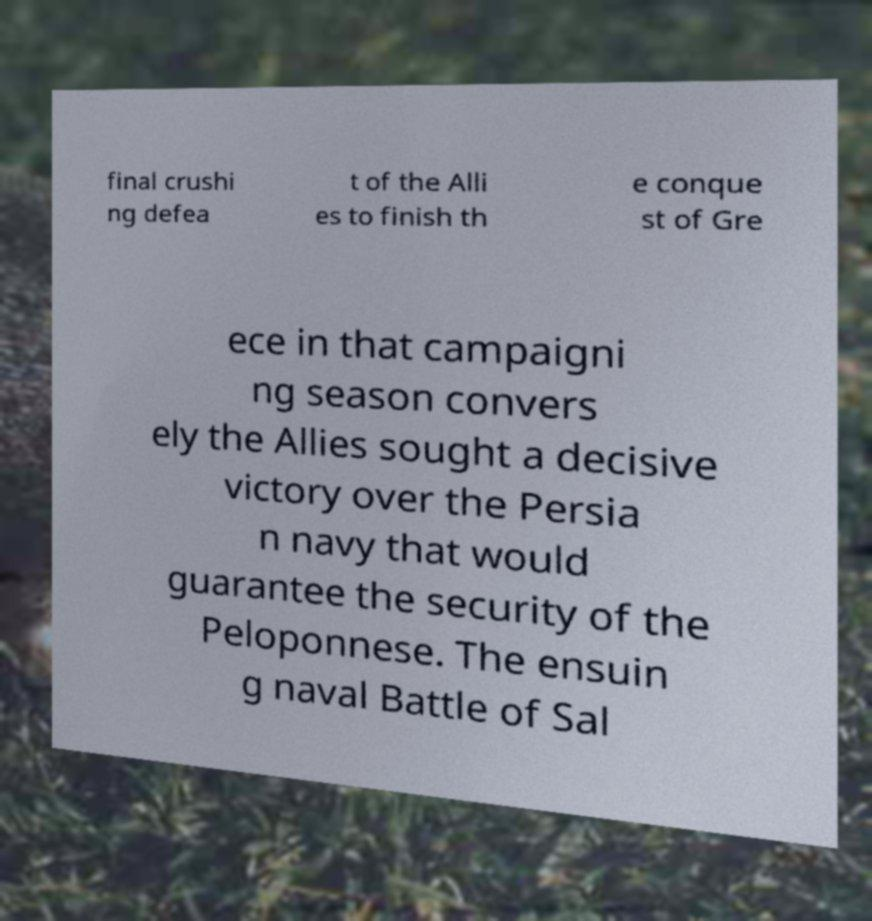Could you extract and type out the text from this image? final crushi ng defea t of the Alli es to finish th e conque st of Gre ece in that campaigni ng season convers ely the Allies sought a decisive victory over the Persia n navy that would guarantee the security of the Peloponnese. The ensuin g naval Battle of Sal 